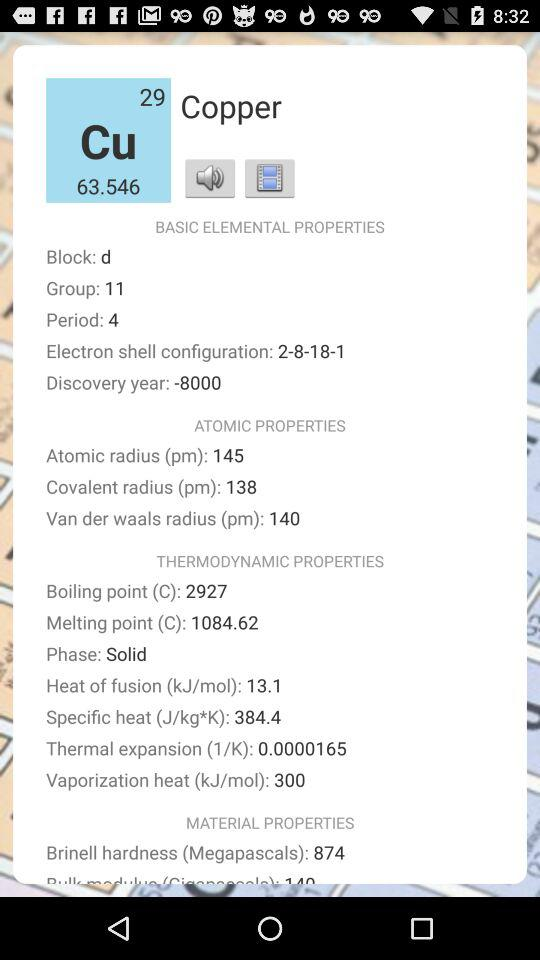What material information is given? The given material is Copper. 